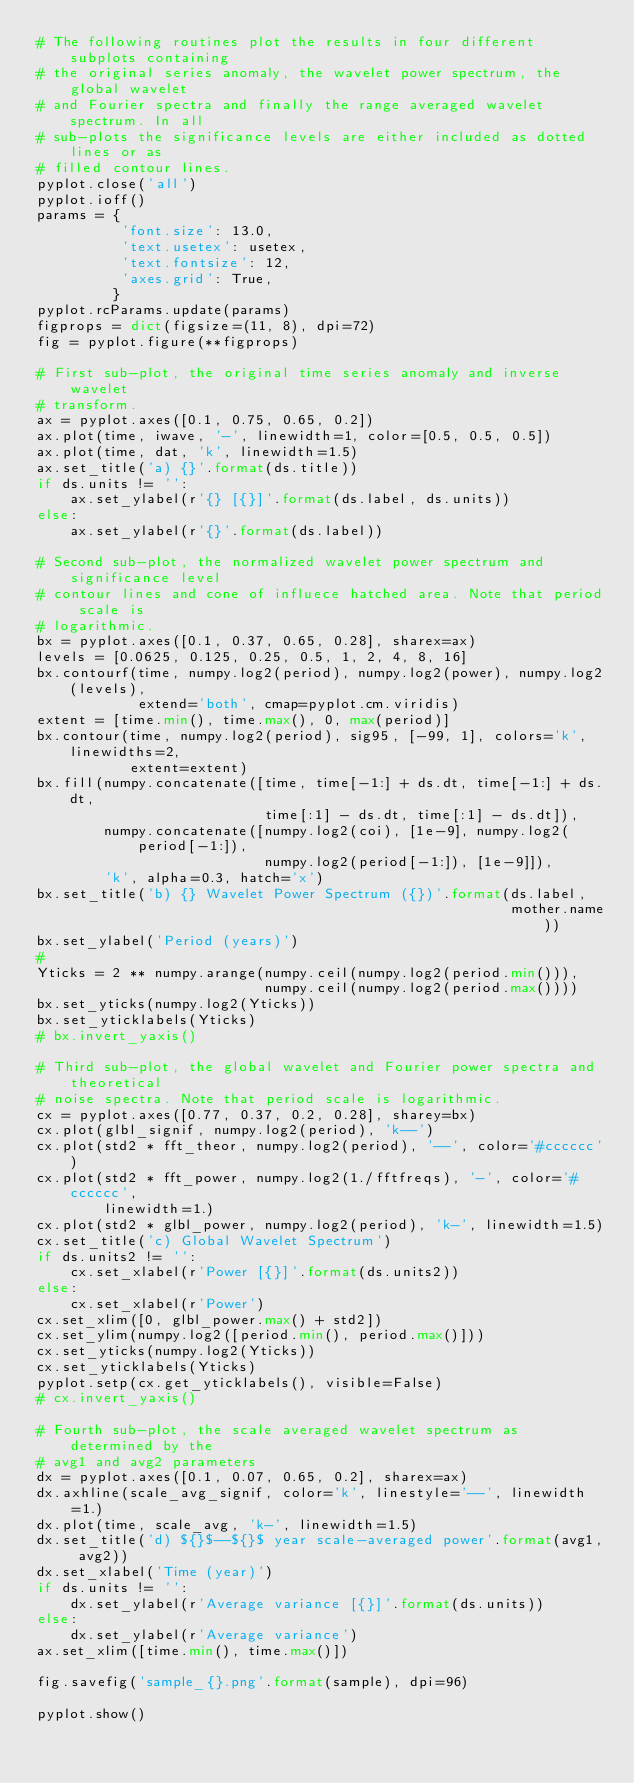Convert code to text. <code><loc_0><loc_0><loc_500><loc_500><_Python_># The following routines plot the results in four different subplots containing
# the original series anomaly, the wavelet power spectrum, the global wavelet
# and Fourier spectra and finally the range averaged wavelet spectrum. In all
# sub-plots the significance levels are either included as dotted lines or as
# filled contour lines.
pyplot.close('all')
pyplot.ioff()
params = {
          'font.size': 13.0,
          'text.usetex': usetex,
          'text.fontsize': 12,
          'axes.grid': True,
         }
pyplot.rcParams.update(params)
figprops = dict(figsize=(11, 8), dpi=72)
fig = pyplot.figure(**figprops)

# First sub-plot, the original time series anomaly and inverse wavelet
# transform.
ax = pyplot.axes([0.1, 0.75, 0.65, 0.2])
ax.plot(time, iwave, '-', linewidth=1, color=[0.5, 0.5, 0.5])
ax.plot(time, dat, 'k', linewidth=1.5)
ax.set_title('a) {}'.format(ds.title))
if ds.units != '':
    ax.set_ylabel(r'{} [{}]'.format(ds.label, ds.units))
else:
    ax.set_ylabel(r'{}'.format(ds.label))

# Second sub-plot, the normalized wavelet power spectrum and significance level
# contour lines and cone of influece hatched area. Note that period scale is
# logarithmic.
bx = pyplot.axes([0.1, 0.37, 0.65, 0.28], sharex=ax)
levels = [0.0625, 0.125, 0.25, 0.5, 1, 2, 4, 8, 16]
bx.contourf(time, numpy.log2(period), numpy.log2(power), numpy.log2(levels),
            extend='both', cmap=pyplot.cm.viridis)
extent = [time.min(), time.max(), 0, max(period)]
bx.contour(time, numpy.log2(period), sig95, [-99, 1], colors='k', linewidths=2,
           extent=extent)
bx.fill(numpy.concatenate([time, time[-1:] + ds.dt, time[-1:] + ds.dt,
                           time[:1] - ds.dt, time[:1] - ds.dt]),
        numpy.concatenate([numpy.log2(coi), [1e-9], numpy.log2(period[-1:]),
                           numpy.log2(period[-1:]), [1e-9]]),
        'k', alpha=0.3, hatch='x')
bx.set_title('b) {} Wavelet Power Spectrum ({})'.format(ds.label,
                                                        mother.name))
bx.set_ylabel('Period (years)')
#
Yticks = 2 ** numpy.arange(numpy.ceil(numpy.log2(period.min())),
                           numpy.ceil(numpy.log2(period.max())))
bx.set_yticks(numpy.log2(Yticks))
bx.set_yticklabels(Yticks)
# bx.invert_yaxis()

# Third sub-plot, the global wavelet and Fourier power spectra and theoretical
# noise spectra. Note that period scale is logarithmic.
cx = pyplot.axes([0.77, 0.37, 0.2, 0.28], sharey=bx)
cx.plot(glbl_signif, numpy.log2(period), 'k--')
cx.plot(std2 * fft_theor, numpy.log2(period), '--', color='#cccccc')
cx.plot(std2 * fft_power, numpy.log2(1./fftfreqs), '-', color='#cccccc',
        linewidth=1.)
cx.plot(std2 * glbl_power, numpy.log2(period), 'k-', linewidth=1.5)
cx.set_title('c) Global Wavelet Spectrum')
if ds.units2 != '':
    cx.set_xlabel(r'Power [{}]'.format(ds.units2))
else:
    cx.set_xlabel(r'Power')
cx.set_xlim([0, glbl_power.max() + std2])
cx.set_ylim(numpy.log2([period.min(), period.max()]))
cx.set_yticks(numpy.log2(Yticks))
cx.set_yticklabels(Yticks)
pyplot.setp(cx.get_yticklabels(), visible=False)
# cx.invert_yaxis()

# Fourth sub-plot, the scale averaged wavelet spectrum as determined by the
# avg1 and avg2 parameters
dx = pyplot.axes([0.1, 0.07, 0.65, 0.2], sharex=ax)
dx.axhline(scale_avg_signif, color='k', linestyle='--', linewidth=1.)
dx.plot(time, scale_avg, 'k-', linewidth=1.5)
dx.set_title('d) ${}$--${}$ year scale-averaged power'.format(avg1, avg2))
dx.set_xlabel('Time (year)')
if ds.units != '':
    dx.set_ylabel(r'Average variance [{}]'.format(ds.units))
else:
    dx.set_ylabel(r'Average variance')
ax.set_xlim([time.min(), time.max()])

fig.savefig('sample_{}.png'.format(sample), dpi=96)

pyplot.show()
</code> 